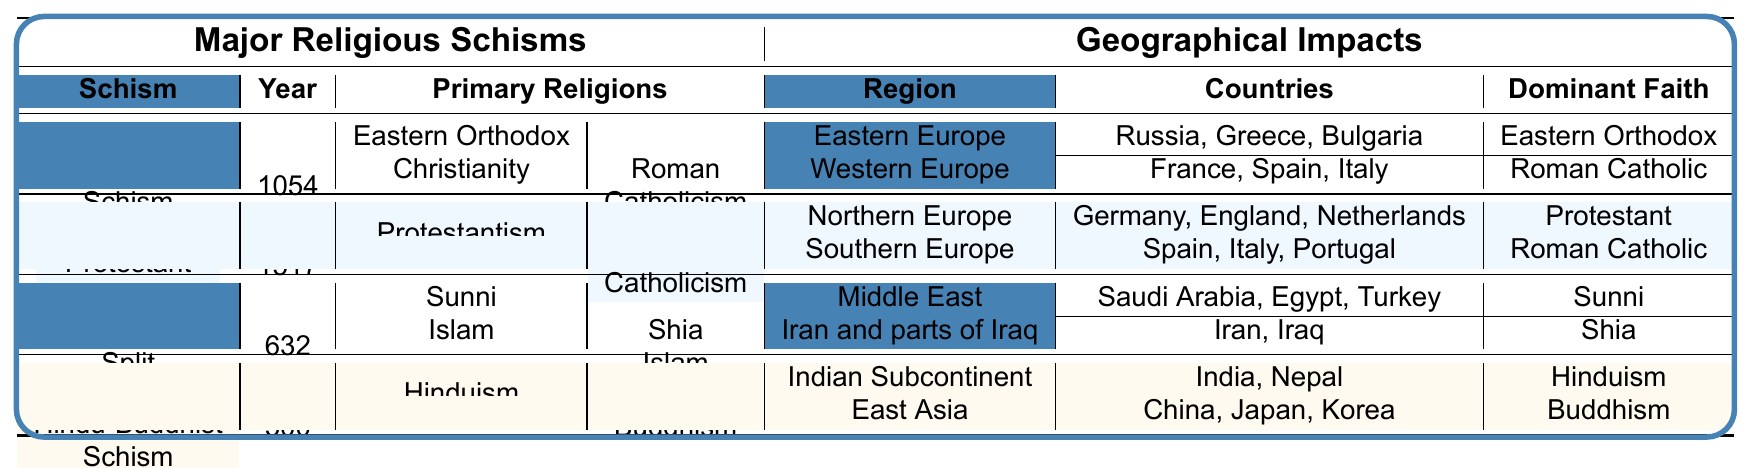What year did the Protestant Reformation occur? The table specifies that the year for the Protestant Reformation is listed under the 'Year' column for that schism, which is 1517.
Answer: 1517 Which region associated with the East-West Schism predominantly follows Eastern Orthodox Christianity? The geographical impacts for the East-West Schism indicate that Eastern Europe, specifically Russia, Greece, and Bulgaria, predominantly follows Eastern Orthodox Christianity.
Answer: Eastern Europe True or False: Shia Islam is the dominant faith in Saudi Arabia according to the table. The table shows that Sunni Islam is the dominant faith in the Middle East, which includes Saudi Arabia, making the statement false.
Answer: False What is the primary religion in Middle Eastern countries affected by the Sunni-Shia Split? According to the table, the dominant faith in the Middle East affected by the Sunni-Shia Split is Sunni Islam.
Answer: Sunni Islam Which two major religions were involved in the Hindu-Buddhist Schism? The table lists Hinduism and Buddhism as the primary religions associated with the Hindu-Buddhist Schism.
Answer: Hinduism and Buddhism In how many regions did the Protestant Reformation have geographical impacts? The table indicates that the Protestant Reformation affected two regions: Northern Europe and Southern Europe, which are both listed under that schism's geographical impacts.
Answer: Two regions Compare the dominant faiths in Eastern Europe and Western Europe due to the East-West Schism. In Eastern Europe, the dominant faith is Eastern Orthodox, while in Western Europe, it is Roman Catholic, as indicated in the table under the corresponding geographical impacts.
Answer: Eastern Orthodox vs. Roman Catholic What is the common trend observed in terms of dominant faiths following significant religious schisms? Analyzing the table suggests that each schism leads either to the establishment of a new dominant faith or a division of existing ones (e.g., Sunni or Shia after the Sunni-Shia split), reflecting significant geographical faith disparities.
Answer: Division of existing faiths Which countries in Northern Europe were affected by the Protestant Reformation? The table lists Germany, England, and the Netherlands as the countries in Northern Europe impacted by the Protestant Reformation under the corresponding geographical impacts.
Answer: Germany, England, Netherlands What was the year of the Sunni-Shia Split, and how does it compare to the East-West Schism? The Sunni-Shia Split occurred in 632, while the East-West Schism occurred in 1054. Comparing both, the Sunni-Shia Split happened earlier than the East-West Schism.
Answer: 632 (earlier than 1054) Identify one country from East Asia that follows Buddhism according to the Hindu-Buddhist Schism. The table shows that China, Japan, and Korea are all listed as countries in East Asia that follow Buddhism due to the Hindu-Buddhist Schism.
Answer: China, Japan, or Korea (any one of them) 